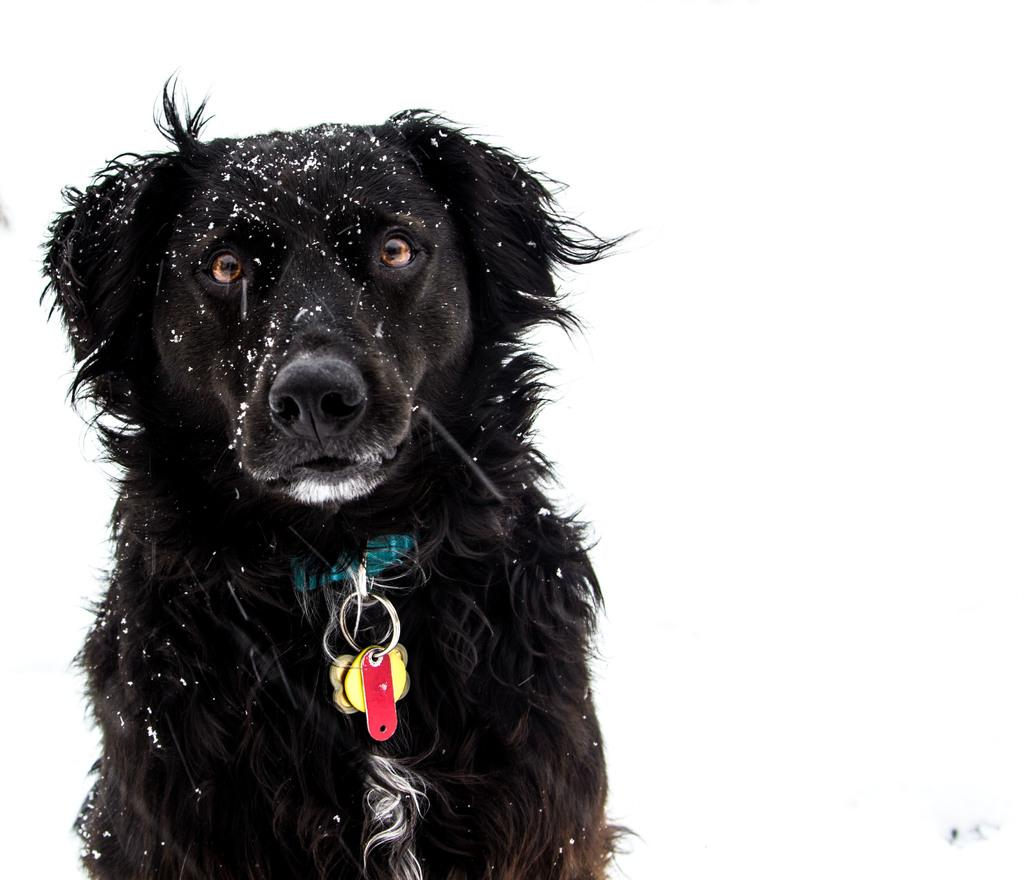What type of animal is in the image? There is a dog in the image. What is the dog wearing? The dog is wearing a chain. What is the color of the background in the image? The background in the image is white. What type of fuel is being used by the cars in the image? There are no cars present in the image, so it is not possible to determine what type of fuel is being used. 